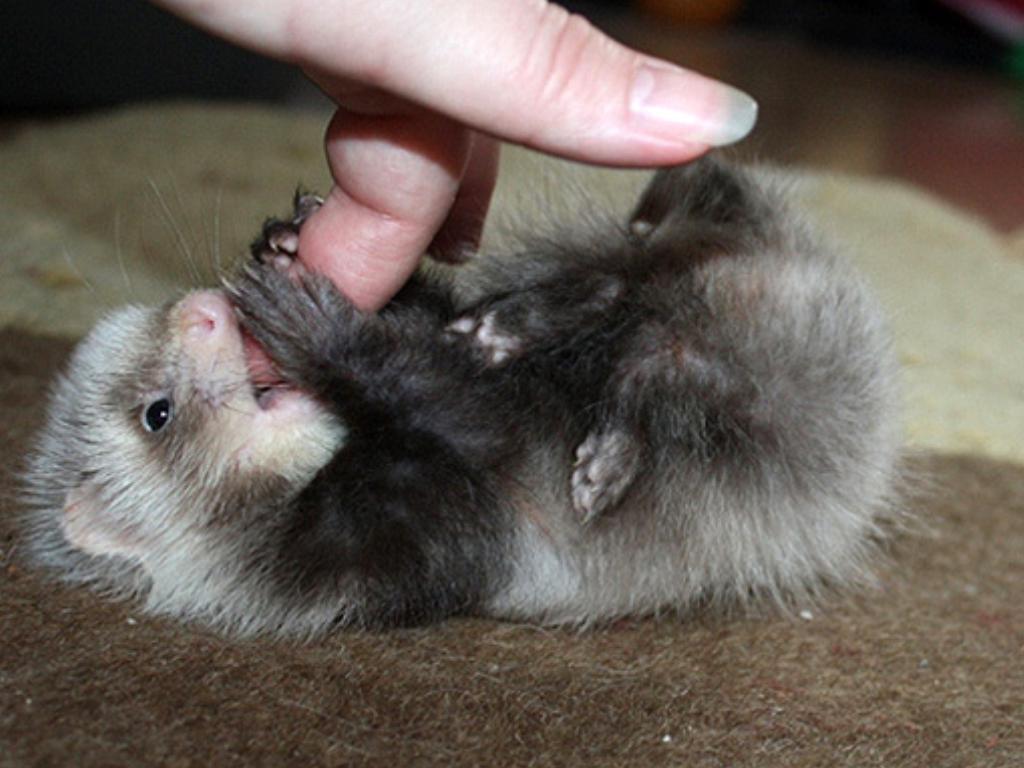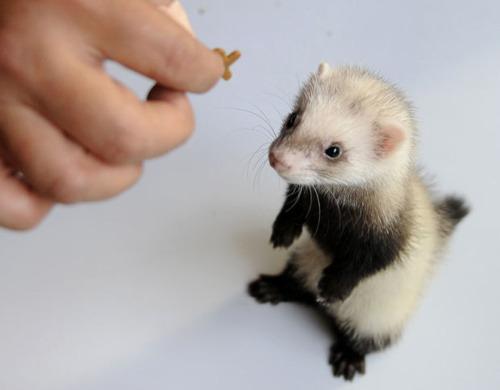The first image is the image on the left, the second image is the image on the right. For the images shown, is this caption "One image contains a pair of ferrets." true? Answer yes or no. No. 